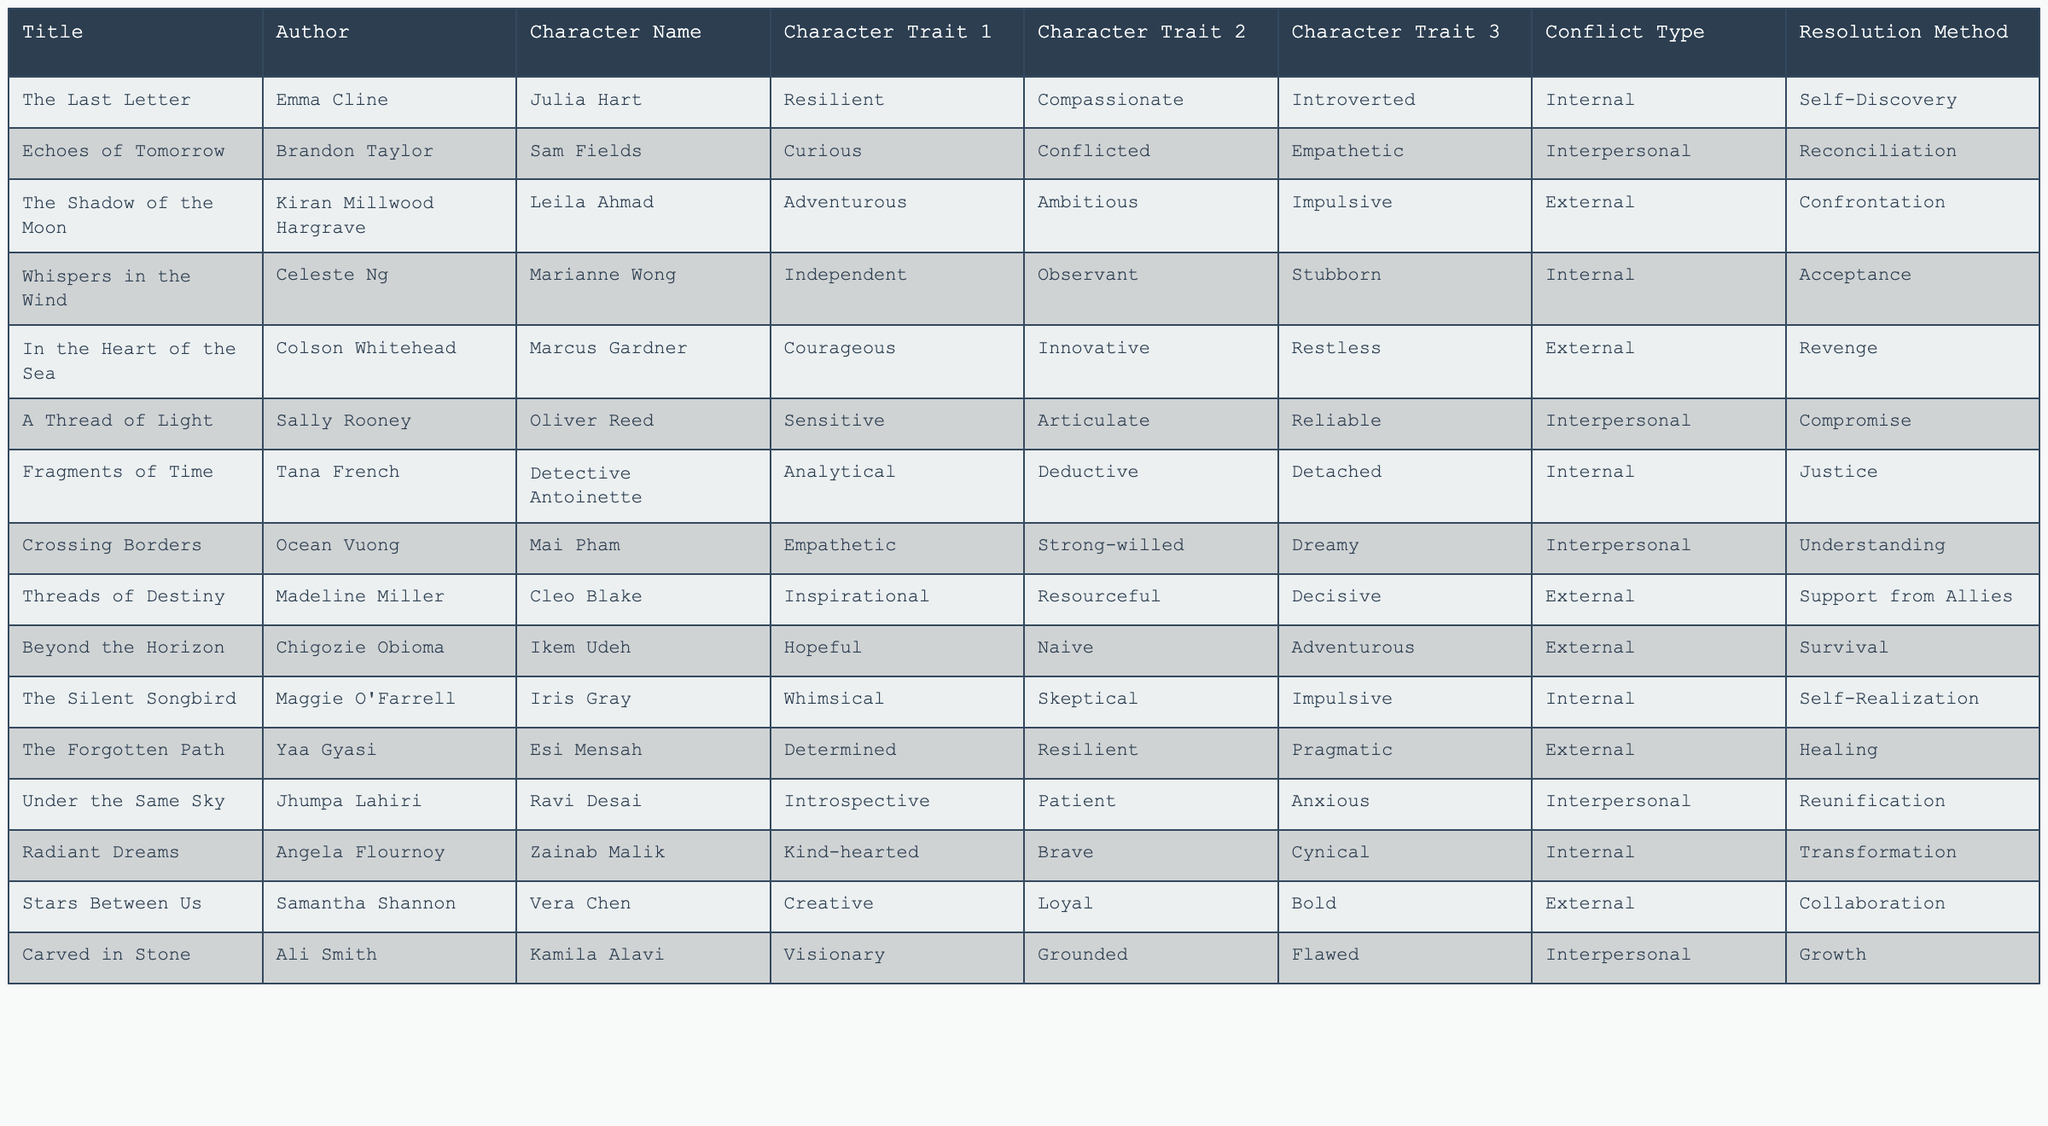What are the character traits of Julia Hart in "The Last Letter"? Julia Hart has the character traits of being resilient, compassionate, and introverted, as listed in the table.
Answer: Resilient, Compassionate, Introverted Which character is described as adventurous and impulsive? In the table, Leila Ahmad from "The Shadow of the Moon" is described as both adventurous and impulsive.
Answer: Leila Ahmad How many characters exhibit empathetic traits? The table lists three characters exhibiting empathetic traits: Sam Fields, Mai Pham, and Oliver Reed. Therefore, the count is three.
Answer: Three Is there a character in the table who is both independent and stubborn? Based on the data, Marianne Wong from "Whispers in the Wind" is characterized as independent and stubborn, which means the answer is yes.
Answer: Yes What is the conflict type for the character Marcus Gardner in "In the Heart of the Sea"? According to the table, the conflict type for Marcus Gardner is classified as external.
Answer: External Which character has the trait of being both determined and resilient? Esi Mensah from "The Forgotten Path" is noted for being determined and resilient, giving us the answer.
Answer: Esi Mensah How many characters have a resolution method classified as reconciliation? There is one character, Sam Fields from "Echoes of Tomorrow," who has a resolution method classified as reconciliation. Thus, the answer is one.
Answer: One What are the character traits of Zainab Malik in "Radiant Dreams"? Zainab Malik's character traits include being kind-hearted, brave, and cynical, as shown in the table.
Answer: Kind-hearted, Brave, Cynical Which character from the table has a conflict type labeled as healing? Esi Mensah from "The Forgotten Path" has a conflict type labeled as healing, answering the question directly.
Answer: Esi Mensah Are there any characters with more than two traits listed in the table? Yes, characters like Julia Hart and Zainab Malik have three traits listed, confirming the presence of multiple traits.
Answer: Yes 